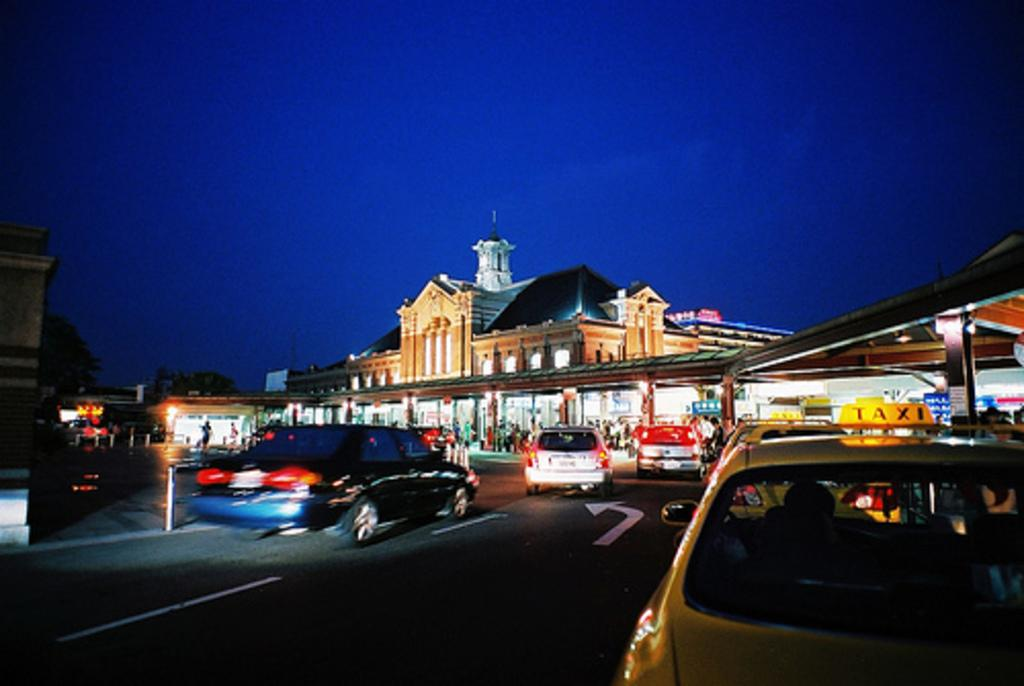<image>
Share a concise interpretation of the image provided. A yellow car that has a TAXI sign on the top of it drives on a street at night with several other cars. 